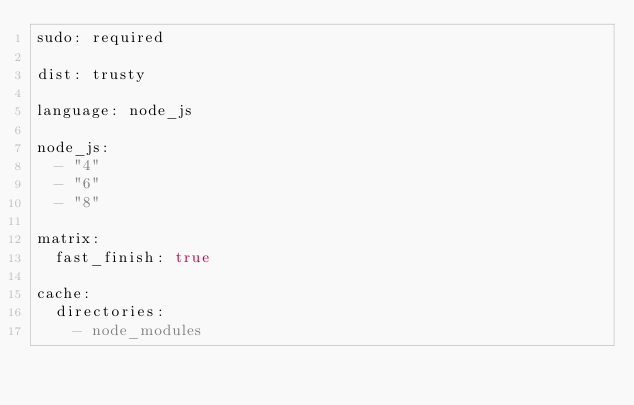Convert code to text. <code><loc_0><loc_0><loc_500><loc_500><_YAML_>sudo: required

dist: trusty

language: node_js

node_js:
  - "4"
  - "6"
  - "8"

matrix:
  fast_finish: true

cache:
  directories:
    - node_modules
</code> 